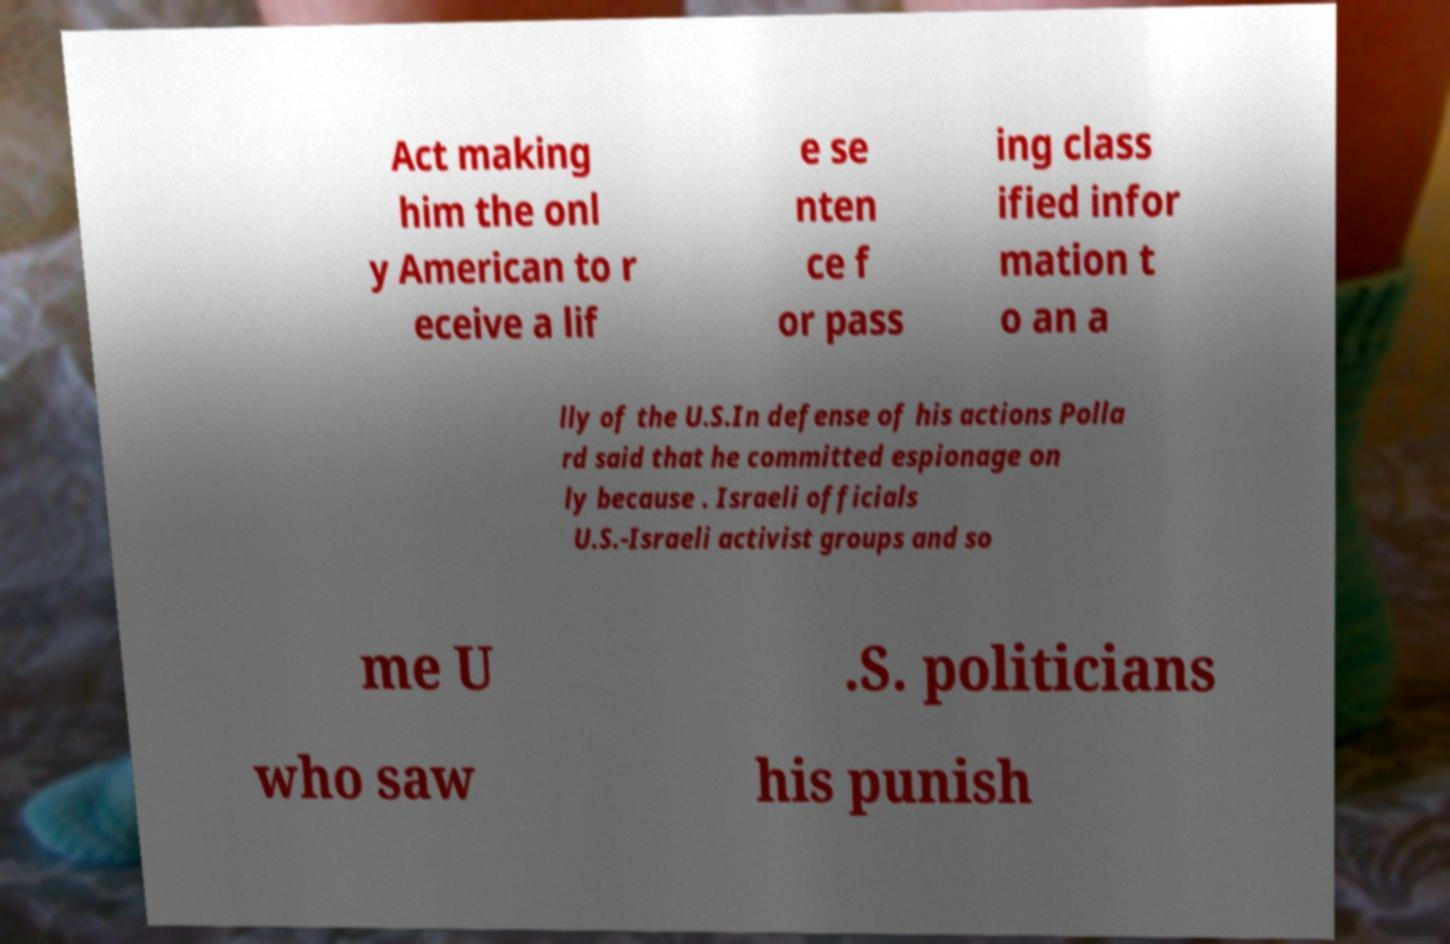Please read and relay the text visible in this image. What does it say? Act making him the onl y American to r eceive a lif e se nten ce f or pass ing class ified infor mation t o an a lly of the U.S.In defense of his actions Polla rd said that he committed espionage on ly because . Israeli officials U.S.-Israeli activist groups and so me U .S. politicians who saw his punish 